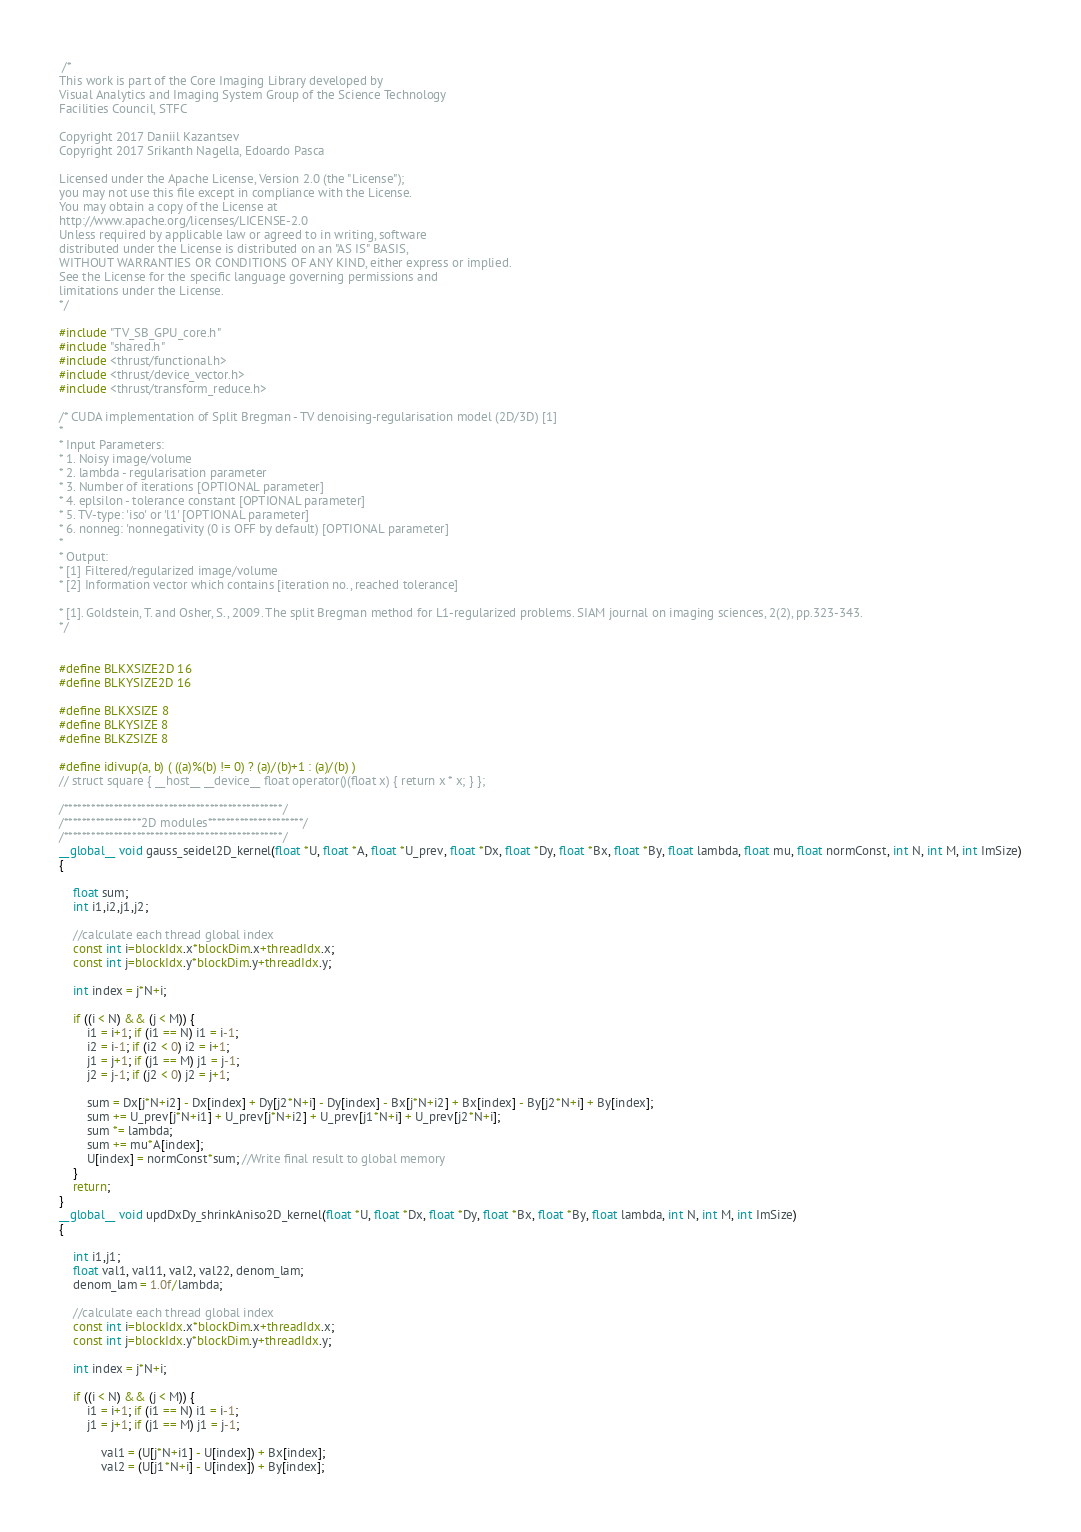<code> <loc_0><loc_0><loc_500><loc_500><_Cuda_> /*
This work is part of the Core Imaging Library developed by
Visual Analytics and Imaging System Group of the Science Technology
Facilities Council, STFC

Copyright 2017 Daniil Kazantsev
Copyright 2017 Srikanth Nagella, Edoardo Pasca

Licensed under the Apache License, Version 2.0 (the "License");
you may not use this file except in compliance with the License.
You may obtain a copy of the License at
http://www.apache.org/licenses/LICENSE-2.0
Unless required by applicable law or agreed to in writing, software
distributed under the License is distributed on an "AS IS" BASIS,
WITHOUT WARRANTIES OR CONDITIONS OF ANY KIND, either express or implied.
See the License for the specific language governing permissions and
limitations under the License.
*/

#include "TV_SB_GPU_core.h"
#include "shared.h"
#include <thrust/functional.h>
#include <thrust/device_vector.h>
#include <thrust/transform_reduce.h>

/* CUDA implementation of Split Bregman - TV denoising-regularisation model (2D/3D) [1]
*
* Input Parameters:
* 1. Noisy image/volume
* 2. lambda - regularisation parameter
* 3. Number of iterations [OPTIONAL parameter]
* 4. eplsilon - tolerance constant [OPTIONAL parameter]
* 5. TV-type: 'iso' or 'l1' [OPTIONAL parameter]
* 6. nonneg: 'nonnegativity (0 is OFF by default) [OPTIONAL parameter]
*
* Output:
* [1] Filtered/regularized image/volume
* [2] Information vector which contains [iteration no., reached tolerance]

* [1]. Goldstein, T. and Osher, S., 2009. The split Bregman method for L1-regularized problems. SIAM journal on imaging sciences, 2(2), pp.323-343.
*/


#define BLKXSIZE2D 16
#define BLKYSIZE2D 16

#define BLKXSIZE 8
#define BLKYSIZE 8
#define BLKZSIZE 8

#define idivup(a, b) ( ((a)%(b) != 0) ? (a)/(b)+1 : (a)/(b) )
// struct square { __host__ __device__ float operator()(float x) { return x * x; } };

/************************************************/
/*****************2D modules*********************/
/************************************************/
__global__ void gauss_seidel2D_kernel(float *U, float *A, float *U_prev, float *Dx, float *Dy, float *Bx, float *By, float lambda, float mu, float normConst, int N, int M, int ImSize)
{

    float sum;
    int i1,i2,j1,j2;

    //calculate each thread global index
    const int i=blockIdx.x*blockDim.x+threadIdx.x;
    const int j=blockIdx.y*blockDim.y+threadIdx.y;

    int index = j*N+i;

    if ((i < N) && (j < M)) {
        i1 = i+1; if (i1 == N) i1 = i-1;
        i2 = i-1; if (i2 < 0) i2 = i+1;
        j1 = j+1; if (j1 == M) j1 = j-1;
        j2 = j-1; if (j2 < 0) j2 = j+1;

        sum = Dx[j*N+i2] - Dx[index] + Dy[j2*N+i] - Dy[index] - Bx[j*N+i2] + Bx[index] - By[j2*N+i] + By[index];
        sum += U_prev[j*N+i1] + U_prev[j*N+i2] + U_prev[j1*N+i] + U_prev[j2*N+i];
        sum *= lambda;
        sum += mu*A[index];
        U[index] = normConst*sum; //Write final result to global memory
    }
    return;
}
__global__ void updDxDy_shrinkAniso2D_kernel(float *U, float *Dx, float *Dy, float *Bx, float *By, float lambda, int N, int M, int ImSize)
{

    int i1,j1;
    float val1, val11, val2, val22, denom_lam;
    denom_lam = 1.0f/lambda;

    //calculate each thread global index
    const int i=blockIdx.x*blockDim.x+threadIdx.x;
    const int j=blockIdx.y*blockDim.y+threadIdx.y;

    int index = j*N+i;

    if ((i < N) && (j < M)) {
        i1 = i+1; if (i1 == N) i1 = i-1;
        j1 = j+1; if (j1 == M) j1 = j-1;

            val1 = (U[j*N+i1] - U[index]) + Bx[index];
            val2 = (U[j1*N+i] - U[index]) + By[index];
</code> 